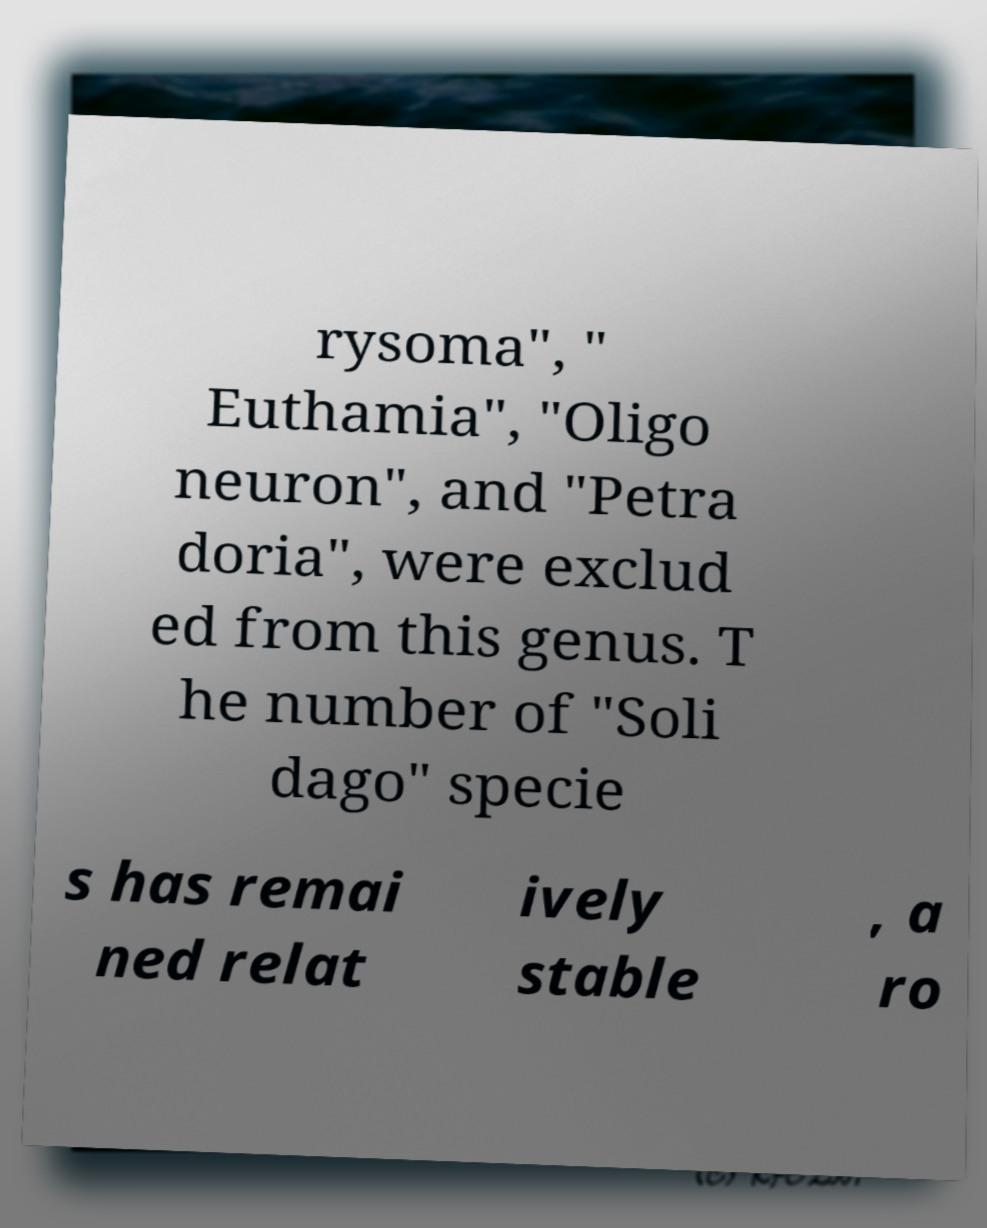Please identify and transcribe the text found in this image. rysoma", " Euthamia", "Oligo neuron", and "Petra doria", were exclud ed from this genus. T he number of "Soli dago" specie s has remai ned relat ively stable , a ro 